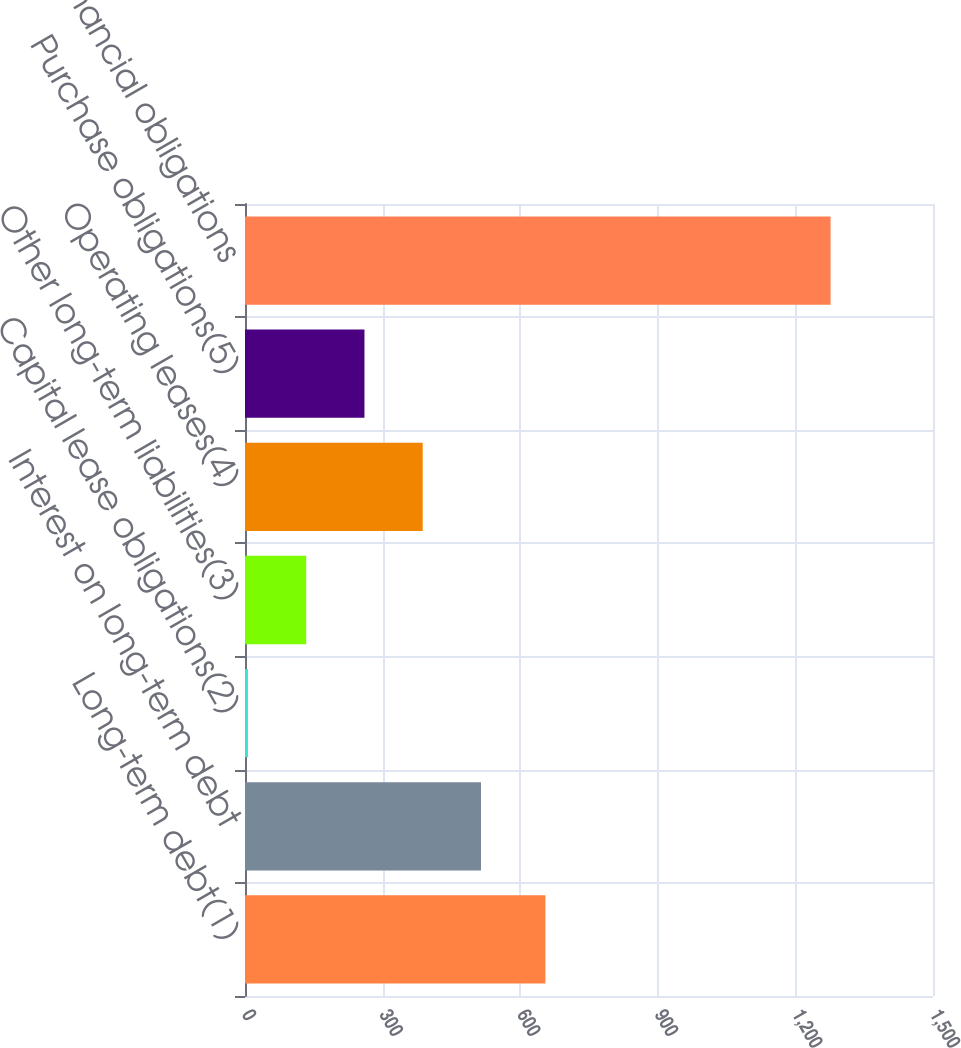<chart> <loc_0><loc_0><loc_500><loc_500><bar_chart><fcel>Long-term debt(1)<fcel>Interest on long-term debt<fcel>Capital lease obligations(2)<fcel>Other long-term liabilities(3)<fcel>Operating leases(4)<fcel>Purchase obligations(5)<fcel>Total financial obligations<nl><fcel>655<fcel>514.52<fcel>6.4<fcel>133.43<fcel>387.49<fcel>260.46<fcel>1276.7<nl></chart> 